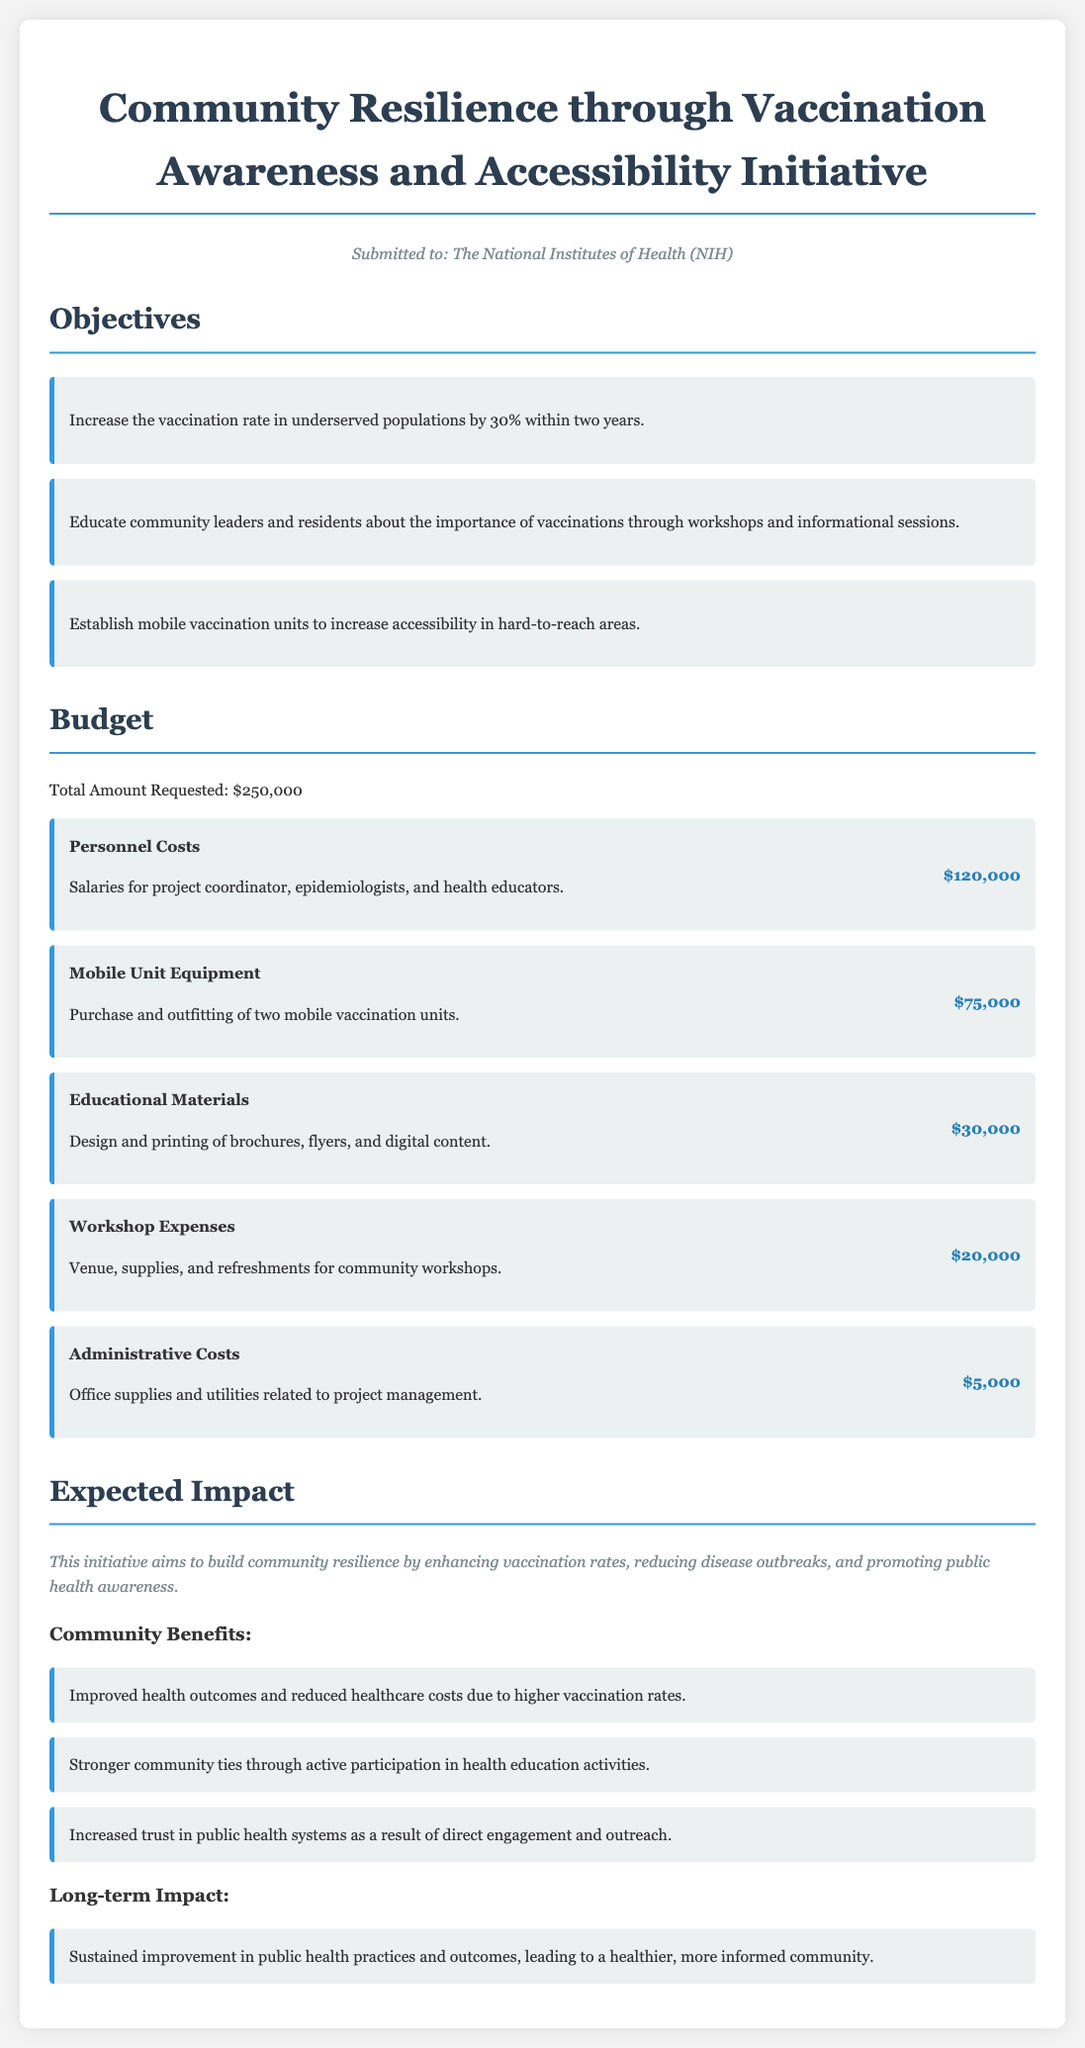what is the total amount requested for the initiative? The total amount requested is stated in the budget section of the document.
Answer: $250,000 how much is allocated for personnel costs? The budget item for personnel costs explicitly lists the amount allocated for salaries and related expenses.
Answer: $120,000 what is one of the objectives of the initiative? The objectives listed in the document include specific goals related to vaccination and education.
Answer: Increase the vaccination rate in underserved populations by 30% within two years which institution is the grant application submitted to? The document clearly mentions the institution to which the application is submitted at the beginning.
Answer: The National Institutes of Health (NIH) what is the expected long-term impact of the initiative? The expected long-term impact summarizes the broader effects anticipated from improved public health practices.
Answer: Sustained improvement in public health practices and outcomes, leading to a healthier, more informed community how many mobile vaccination units will be purchased? The budget item for mobile unit equipment specifies the number of units being considered for purchase.
Answer: Two what type of materials are included in the educational budget? One of the budget items mentions specific resources allocated for educational purposes.
Answer: Brochures, flyers, and digital content what type of expenses is included for workshops? The budget specifies what financial considerations are included for conducting workshops.
Answer: Venue, supplies, and refreshments for community workshops 